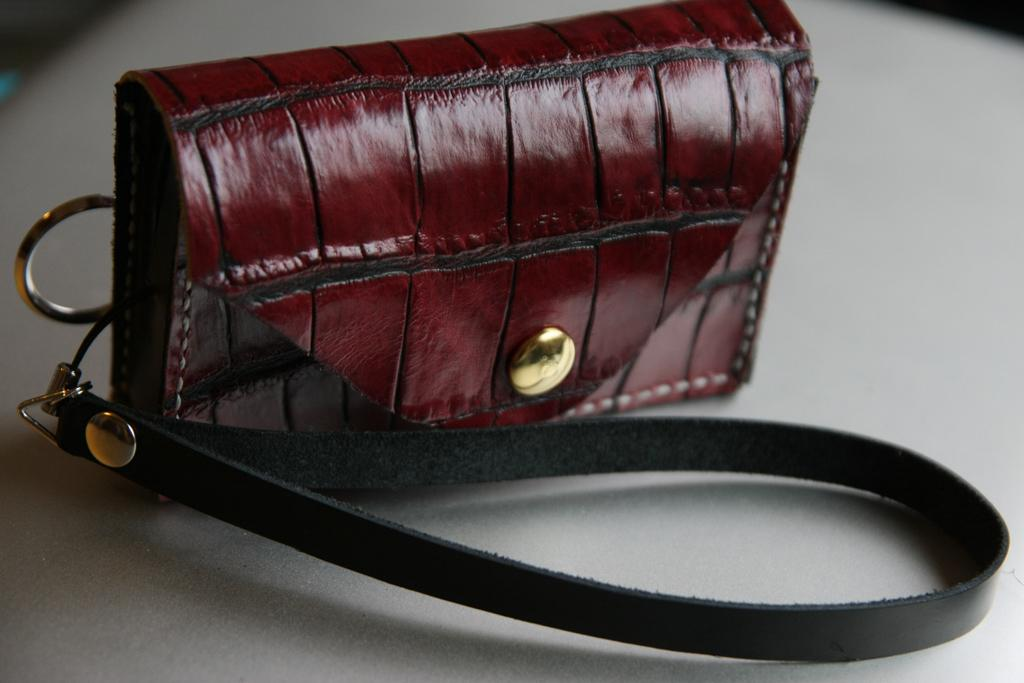What is the color of the handbag in the image? The handbag in the image is red. Can you describe the type of item in the image? The item in the image is a handbag. What type of skin is visible on the handbag in the image? There is no skin visible on the handbag in the image; it is an inanimate object made of fabric or other materials. 